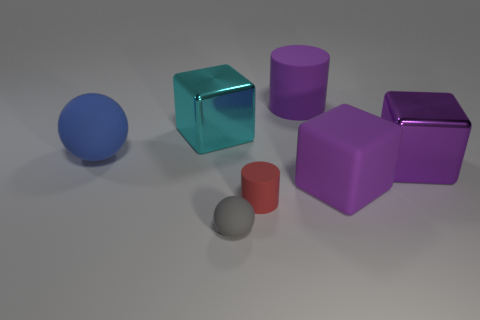What material is the cylinder that is the same color as the large matte block?
Make the answer very short. Rubber. There is a metal cube on the left side of the large purple thing behind the metal object on the left side of the small matte cylinder; what size is it?
Ensure brevity in your answer.  Large. There is a tiny gray sphere; are there any small cylinders in front of it?
Your response must be concise. No. There is a blue sphere; is its size the same as the rubber sphere in front of the purple shiny thing?
Ensure brevity in your answer.  No. What number of other objects are the same material as the blue object?
Your answer should be very brief. 4. What is the shape of the matte thing that is both in front of the big rubber cylinder and to the right of the red cylinder?
Keep it short and to the point. Cube. There is a gray rubber object that is in front of the tiny red matte thing; does it have the same size as the metallic object to the right of the gray rubber thing?
Offer a terse response. No. What shape is the gray thing that is made of the same material as the big blue sphere?
Provide a short and direct response. Sphere. Are there any other things that have the same shape as the small red object?
Your answer should be very brief. Yes. There is a large thing on the left side of the metal object that is on the left side of the cylinder in front of the big ball; what color is it?
Offer a terse response. Blue. 